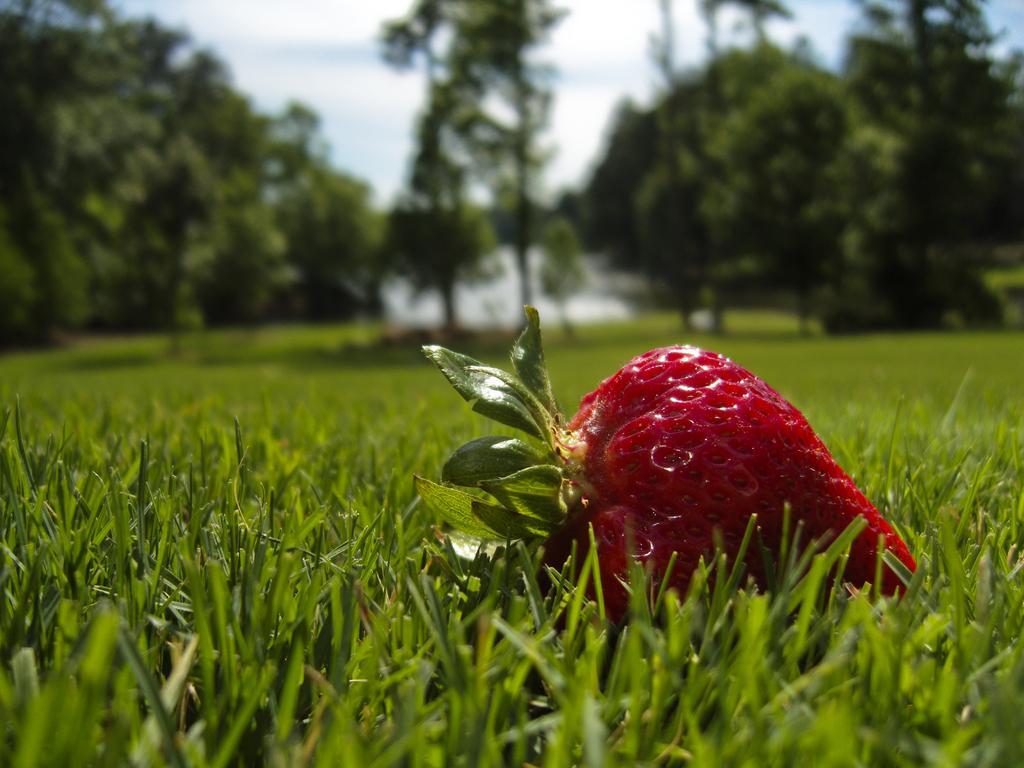Please provide a concise description of this image. In this image there is a strawberry on the surface of the grass. In the background there are trees. 